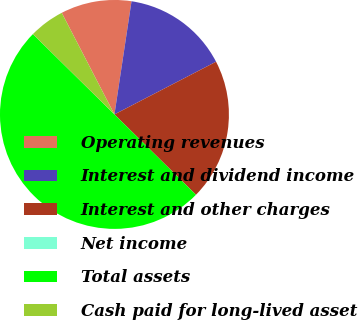Convert chart. <chart><loc_0><loc_0><loc_500><loc_500><pie_chart><fcel>Operating revenues<fcel>Interest and dividend income<fcel>Interest and other charges<fcel>Net income<fcel>Total assets<fcel>Cash paid for long-lived asset<nl><fcel>10.0%<fcel>15.0%<fcel>20.0%<fcel>0.0%<fcel>50.0%<fcel>5.0%<nl></chart> 